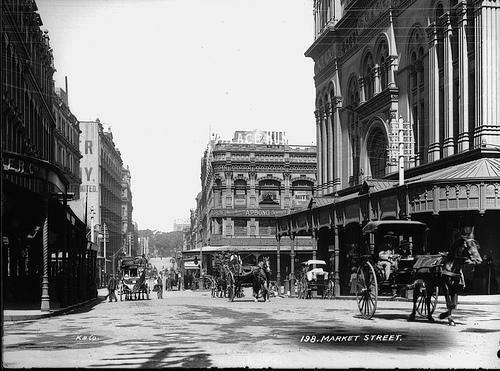How many animals shown?
Give a very brief answer. 2. How many vehicles are shown?
Give a very brief answer. 4. How many horses are there?
Give a very brief answer. 2. How many horses are in the picture?
Give a very brief answer. 1. How many zebras are here?
Give a very brief answer. 0. 